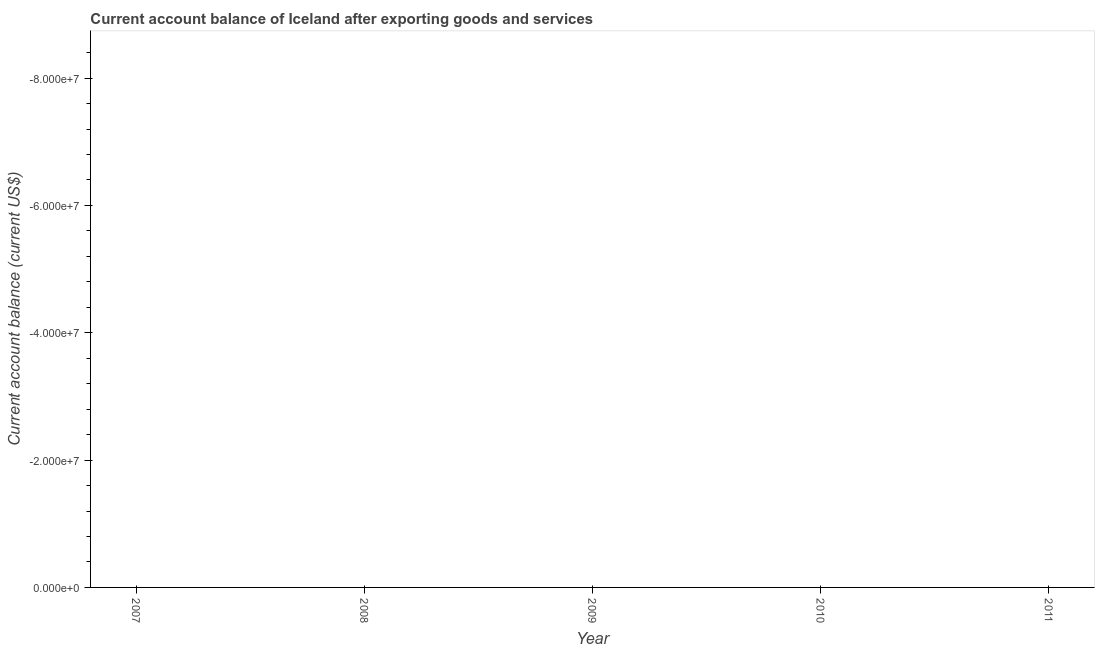What is the current account balance in 2008?
Your response must be concise. 0. What is the sum of the current account balance?
Keep it short and to the point. 0. Does the current account balance monotonically increase over the years?
Your response must be concise. No. What is the difference between two consecutive major ticks on the Y-axis?
Keep it short and to the point. 2.00e+07. Are the values on the major ticks of Y-axis written in scientific E-notation?
Make the answer very short. Yes. Does the graph contain grids?
Your answer should be very brief. No. What is the title of the graph?
Offer a terse response. Current account balance of Iceland after exporting goods and services. What is the label or title of the Y-axis?
Your response must be concise. Current account balance (current US$). What is the Current account balance (current US$) in 2010?
Provide a succinct answer. 0. What is the Current account balance (current US$) in 2011?
Provide a succinct answer. 0. 